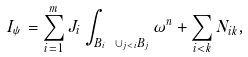Convert formula to latex. <formula><loc_0><loc_0><loc_500><loc_500>I _ { \psi } = \sum _ { i = 1 } ^ { m } J _ { i } \int _ { B _ { i } \ \cup _ { j < i } B _ { j } } \omega ^ { n } + \sum _ { i < k } N _ { i k } ,</formula> 